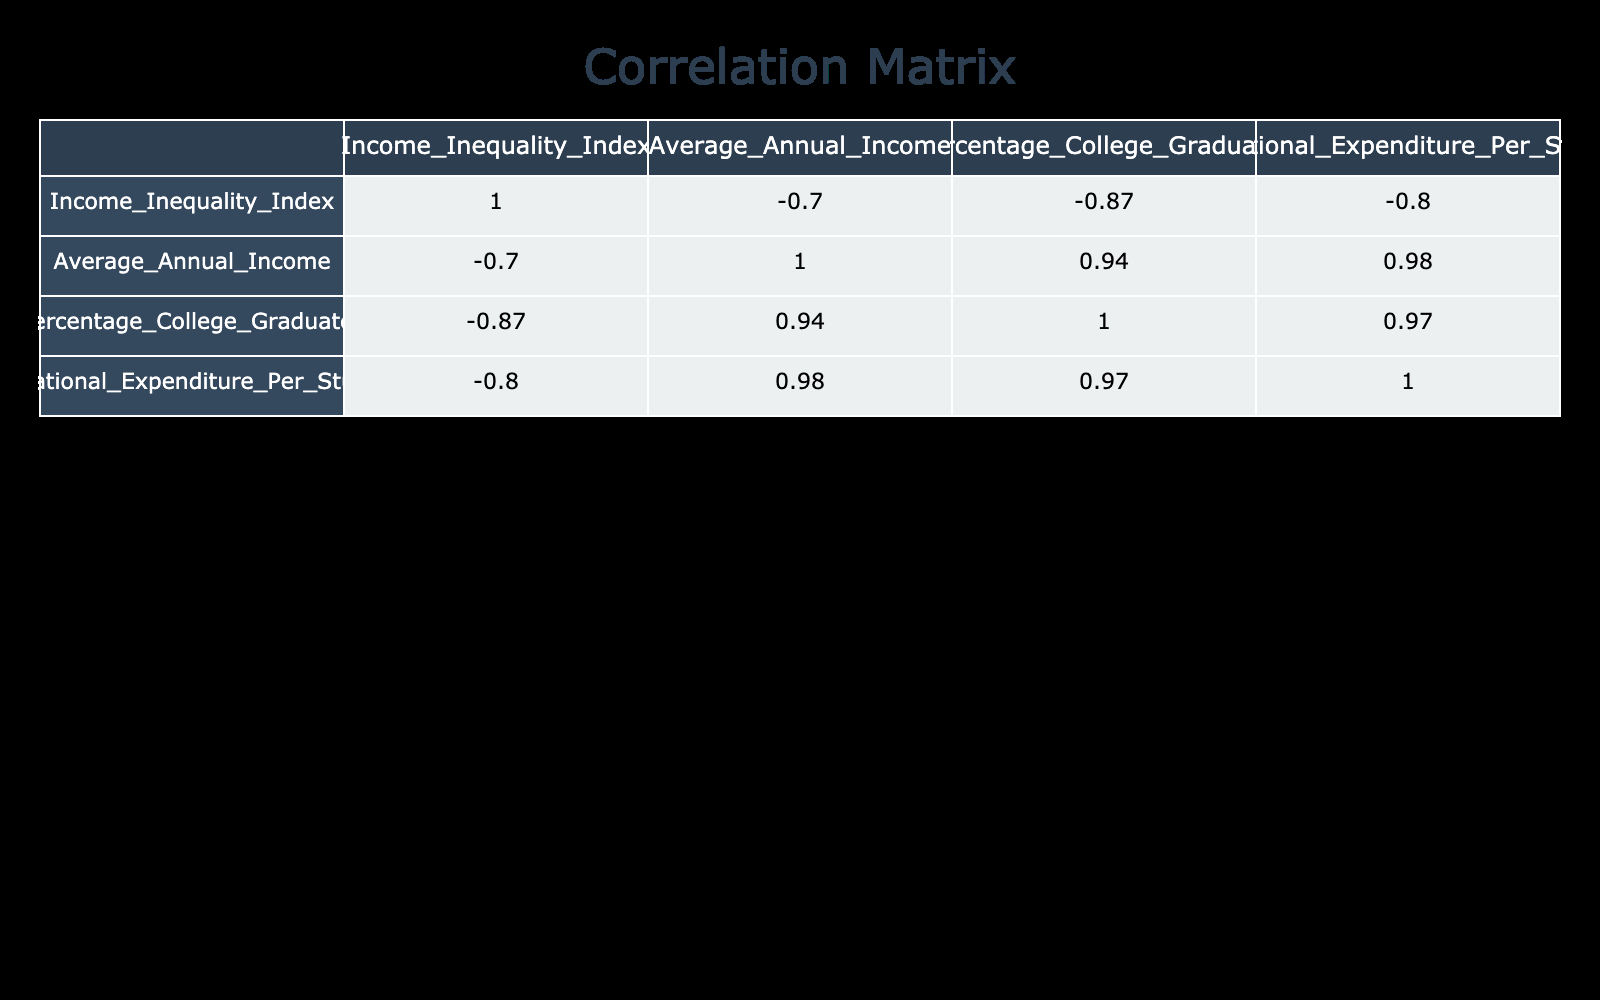What is the Income Inequality Index for Sub-Saharan Africa? The table directly lists the Income Inequality Index for Sub-Saharan Africa as 0.54
Answer: 0.54 Which region has the highest Average Annual Income? By looking at the Average Annual Income column, North America has the highest value at 62000.
Answer: 62000 Is the Percentage of College Graduates in Western Europe higher than in South America? The table shows that Western Europe has 45% college graduates while South America has only 25%, so yes, it is higher.
Answer: Yes What is the average Educational Expenditure Per Student across all regions? Calculate the total of Educational Expenditure Per Student by adding all values (12000 + 10000 + 8000 + 4000 + 2000 + 5000 + 3000 + 9000) = 50000. Then divide by the number of regions (8), resulting in an average of 6250.
Answer: 6250 Are the Income Inequality Index and the Average Annual Income negatively correlated? The correlation coefficient between the Income Inequality Index and Average Annual Income is -0.88 (calculated from the correlation matrix), indicating a strong negative correlation: as income inequality increases, average income tends to decrease.
Answer: Yes What is the difference in Average Annual Income between Oceania and South Asia? Oceania has an Average Annual Income of 55000, while South Asia has 12000. The difference is 55000 - 12000 = 43000.
Answer: 43000 Which region has both the lowest Percentage of College Graduates and the highest Income Inequality Index? Sub-Saharan Africa has the lowest Percentage of College Graduates at 10% and the highest Income Inequality Index of 0.54 among all regions based on the given data.
Answer: Sub-Saharan Africa What is the total of all regions' Educational Expenditure Per Student? Adding up all Educational Expenditure Per Student (12000 + 10000 + 8000 + 4000 + 2000 + 5000 + 3000 + 9000) equals 50000.
Answer: 50000 Which regions have an Income Inequality Index above 0.40? The regions with an Income Inequality Index above 0.40 are North America (0.41), South America (0.45), Sub-Saharan Africa (0.54), South Asia (0.49), and the Middle East (0.42).
Answer: North America, South America, Sub-Saharan Africa, South Asia, Middle East 